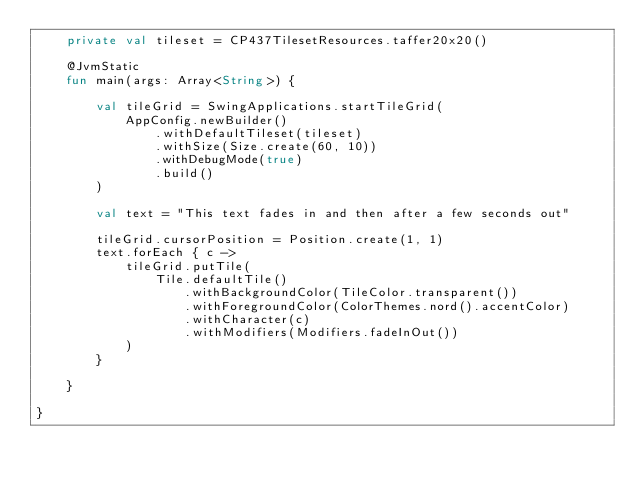Convert code to text. <code><loc_0><loc_0><loc_500><loc_500><_Kotlin_>    private val tileset = CP437TilesetResources.taffer20x20()

    @JvmStatic
    fun main(args: Array<String>) {

        val tileGrid = SwingApplications.startTileGrid(
            AppConfig.newBuilder()
                .withDefaultTileset(tileset)
                .withSize(Size.create(60, 10))
                .withDebugMode(true)
                .build()
        )

        val text = "This text fades in and then after a few seconds out"

        tileGrid.cursorPosition = Position.create(1, 1)
        text.forEach { c ->
            tileGrid.putTile(
                Tile.defaultTile()
                    .withBackgroundColor(TileColor.transparent())
                    .withForegroundColor(ColorThemes.nord().accentColor)
                    .withCharacter(c)
                    .withModifiers(Modifiers.fadeInOut())
            )
        }

    }

}












</code> 